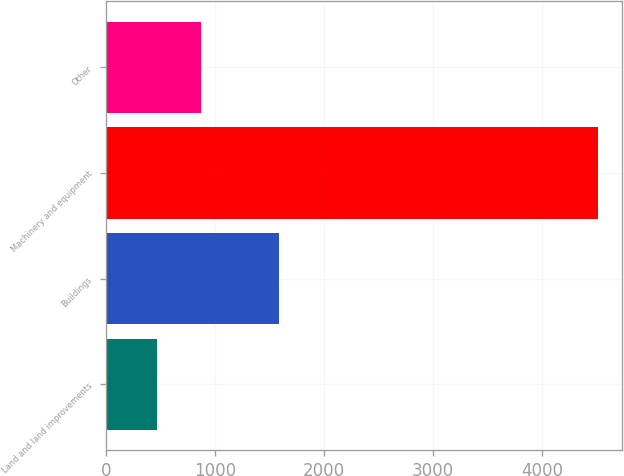Convert chart. <chart><loc_0><loc_0><loc_500><loc_500><bar_chart><fcel>Land and land improvements<fcel>Buildings<fcel>Machinery and equipment<fcel>Other<nl><fcel>473<fcel>1593<fcel>4513<fcel>877<nl></chart> 